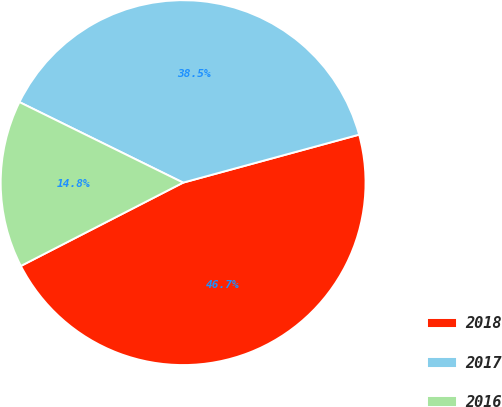Convert chart. <chart><loc_0><loc_0><loc_500><loc_500><pie_chart><fcel>2018<fcel>2017<fcel>2016<nl><fcel>46.69%<fcel>38.49%<fcel>14.83%<nl></chart> 